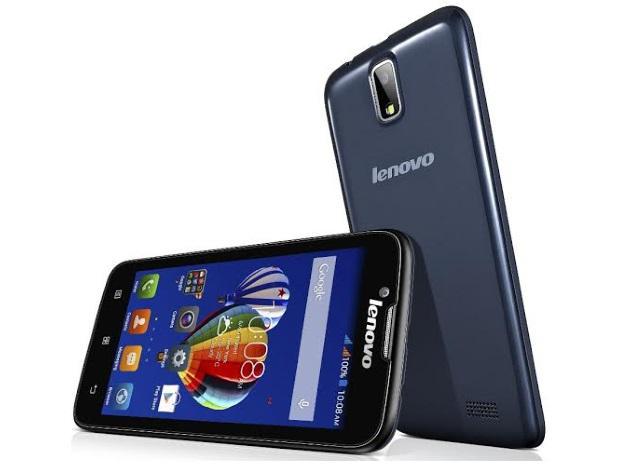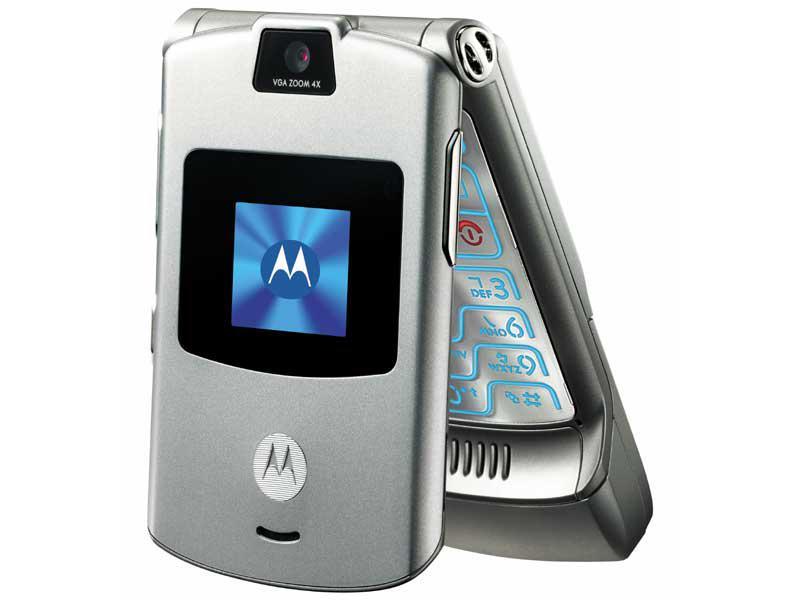The first image is the image on the left, the second image is the image on the right. For the images displayed, is the sentence "At least one flip phone is visible in the right image." factually correct? Answer yes or no. Yes. The first image is the image on the left, the second image is the image on the right. Examine the images to the left and right. Is the description "Three or fewer phones are visible." accurate? Answer yes or no. Yes. 